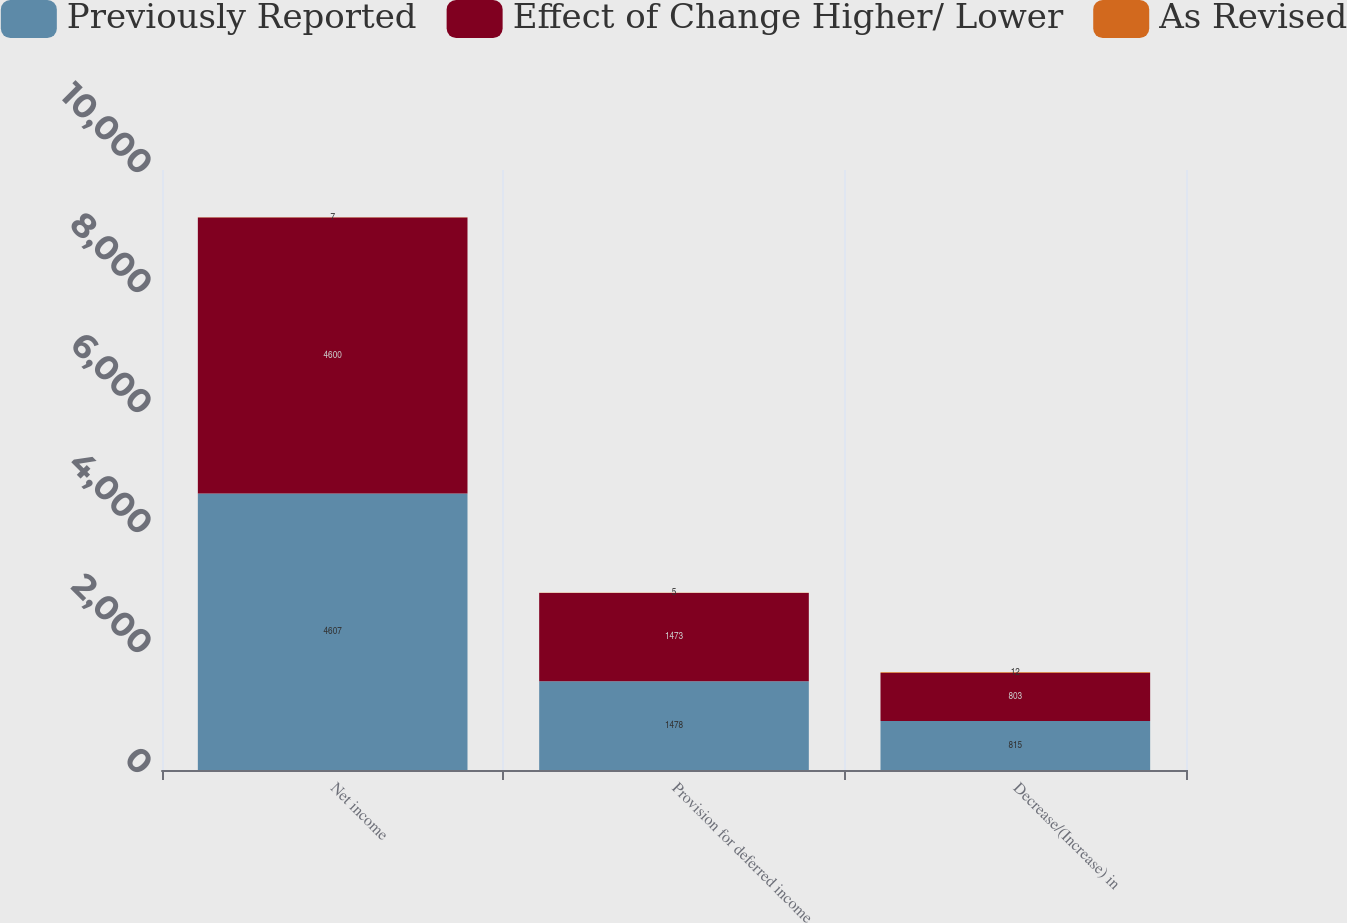<chart> <loc_0><loc_0><loc_500><loc_500><stacked_bar_chart><ecel><fcel>Net income<fcel>Provision for deferred income<fcel>Decrease/(Increase) in<nl><fcel>Previously Reported<fcel>4607<fcel>1478<fcel>815<nl><fcel>Effect of Change Higher/ Lower<fcel>4600<fcel>1473<fcel>803<nl><fcel>As Revised<fcel>7<fcel>5<fcel>12<nl></chart> 